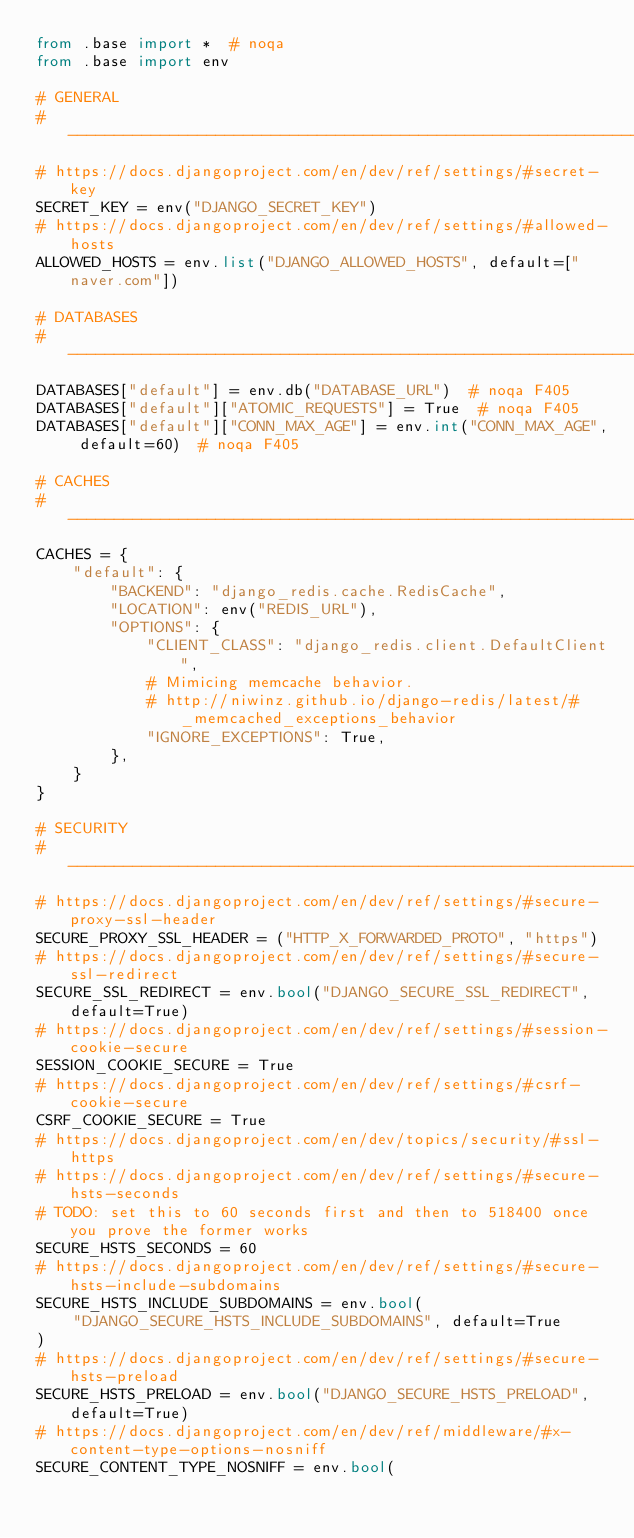Convert code to text. <code><loc_0><loc_0><loc_500><loc_500><_Python_>from .base import *  # noqa
from .base import env

# GENERAL
# ------------------------------------------------------------------------------
# https://docs.djangoproject.com/en/dev/ref/settings/#secret-key
SECRET_KEY = env("DJANGO_SECRET_KEY")
# https://docs.djangoproject.com/en/dev/ref/settings/#allowed-hosts
ALLOWED_HOSTS = env.list("DJANGO_ALLOWED_HOSTS", default=["naver.com"])

# DATABASES
# ------------------------------------------------------------------------------
DATABASES["default"] = env.db("DATABASE_URL")  # noqa F405
DATABASES["default"]["ATOMIC_REQUESTS"] = True  # noqa F405
DATABASES["default"]["CONN_MAX_AGE"] = env.int("CONN_MAX_AGE", default=60)  # noqa F405

# CACHES
# ------------------------------------------------------------------------------
CACHES = {
    "default": {
        "BACKEND": "django_redis.cache.RedisCache",
        "LOCATION": env("REDIS_URL"),
        "OPTIONS": {
            "CLIENT_CLASS": "django_redis.client.DefaultClient",
            # Mimicing memcache behavior.
            # http://niwinz.github.io/django-redis/latest/#_memcached_exceptions_behavior
            "IGNORE_EXCEPTIONS": True,
        },
    }
}

# SECURITY
# ------------------------------------------------------------------------------
# https://docs.djangoproject.com/en/dev/ref/settings/#secure-proxy-ssl-header
SECURE_PROXY_SSL_HEADER = ("HTTP_X_FORWARDED_PROTO", "https")
# https://docs.djangoproject.com/en/dev/ref/settings/#secure-ssl-redirect
SECURE_SSL_REDIRECT = env.bool("DJANGO_SECURE_SSL_REDIRECT", default=True)
# https://docs.djangoproject.com/en/dev/ref/settings/#session-cookie-secure
SESSION_COOKIE_SECURE = True
# https://docs.djangoproject.com/en/dev/ref/settings/#csrf-cookie-secure
CSRF_COOKIE_SECURE = True
# https://docs.djangoproject.com/en/dev/topics/security/#ssl-https
# https://docs.djangoproject.com/en/dev/ref/settings/#secure-hsts-seconds
# TODO: set this to 60 seconds first and then to 518400 once you prove the former works
SECURE_HSTS_SECONDS = 60
# https://docs.djangoproject.com/en/dev/ref/settings/#secure-hsts-include-subdomains
SECURE_HSTS_INCLUDE_SUBDOMAINS = env.bool(
    "DJANGO_SECURE_HSTS_INCLUDE_SUBDOMAINS", default=True
)
# https://docs.djangoproject.com/en/dev/ref/settings/#secure-hsts-preload
SECURE_HSTS_PRELOAD = env.bool("DJANGO_SECURE_HSTS_PRELOAD", default=True)
# https://docs.djangoproject.com/en/dev/ref/middleware/#x-content-type-options-nosniff
SECURE_CONTENT_TYPE_NOSNIFF = env.bool(</code> 